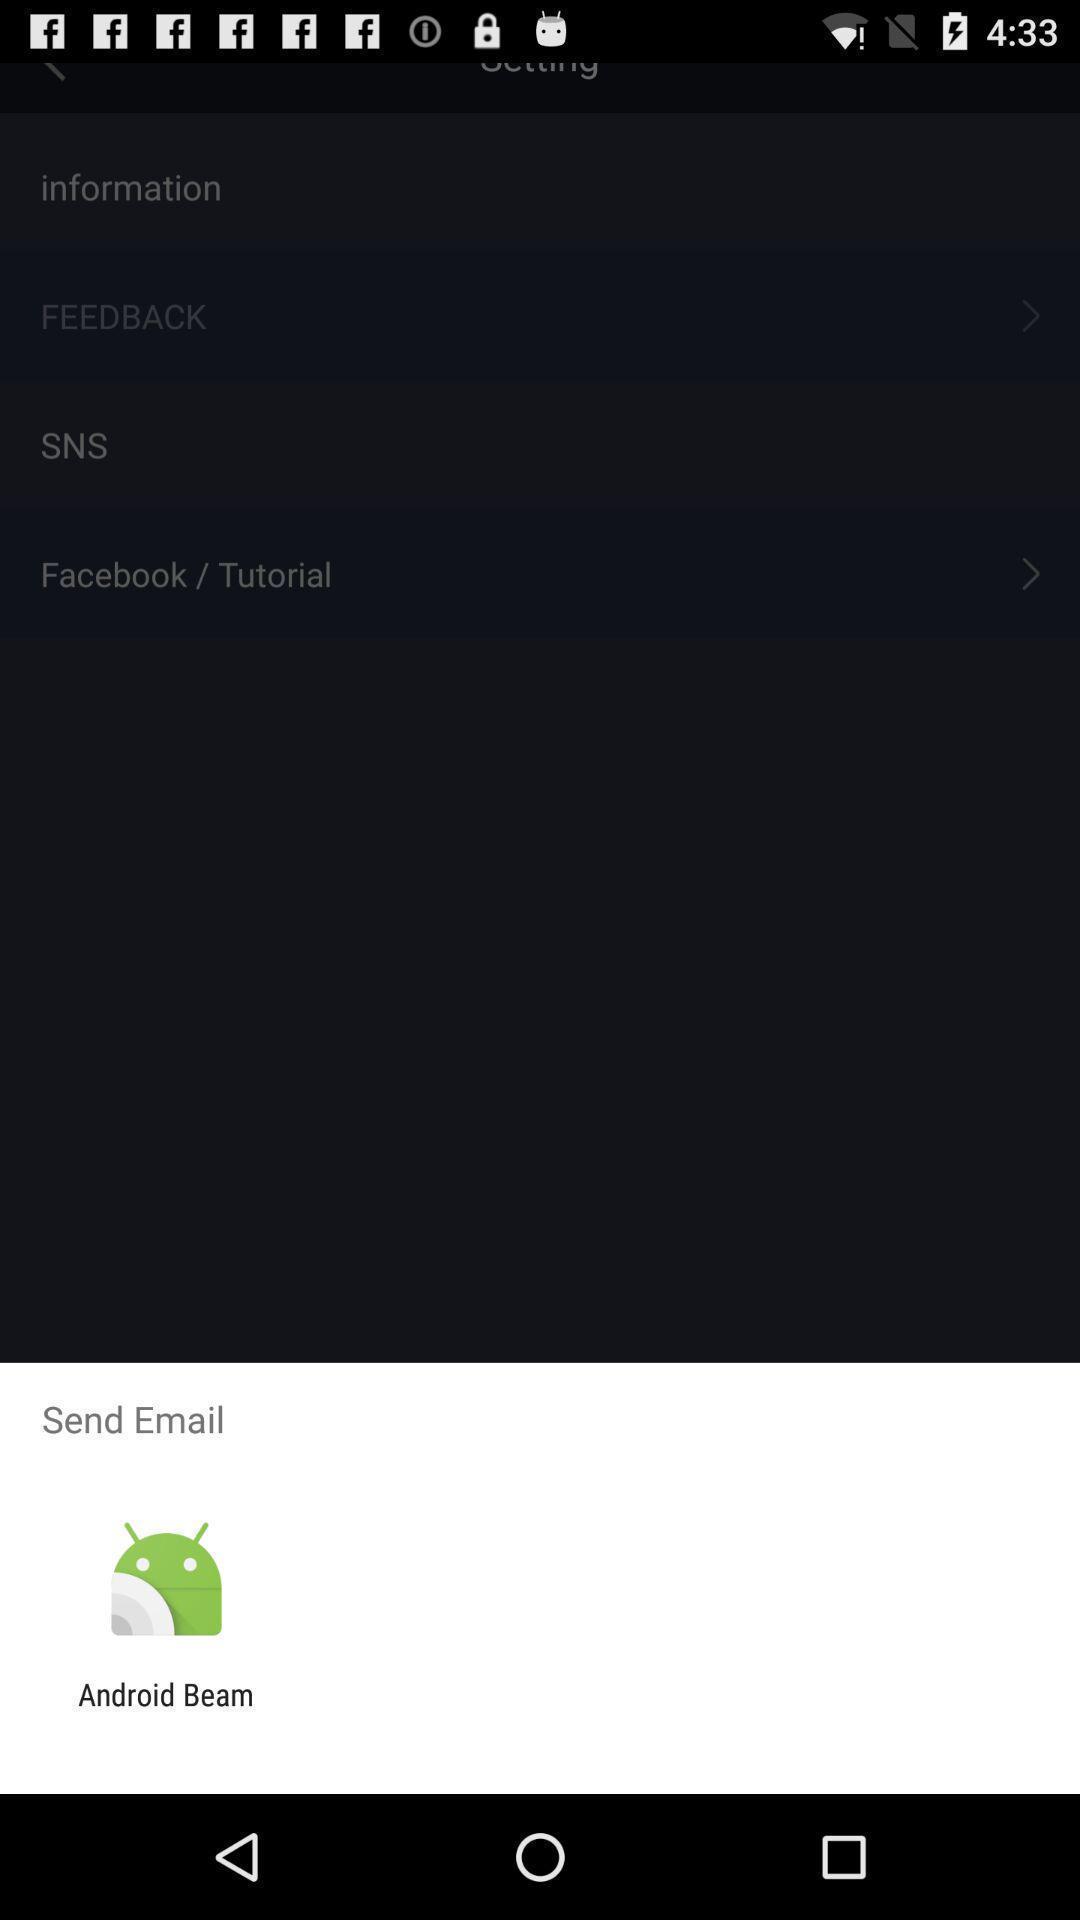Describe the visual elements of this screenshot. Push up message of sending mail via other application. 